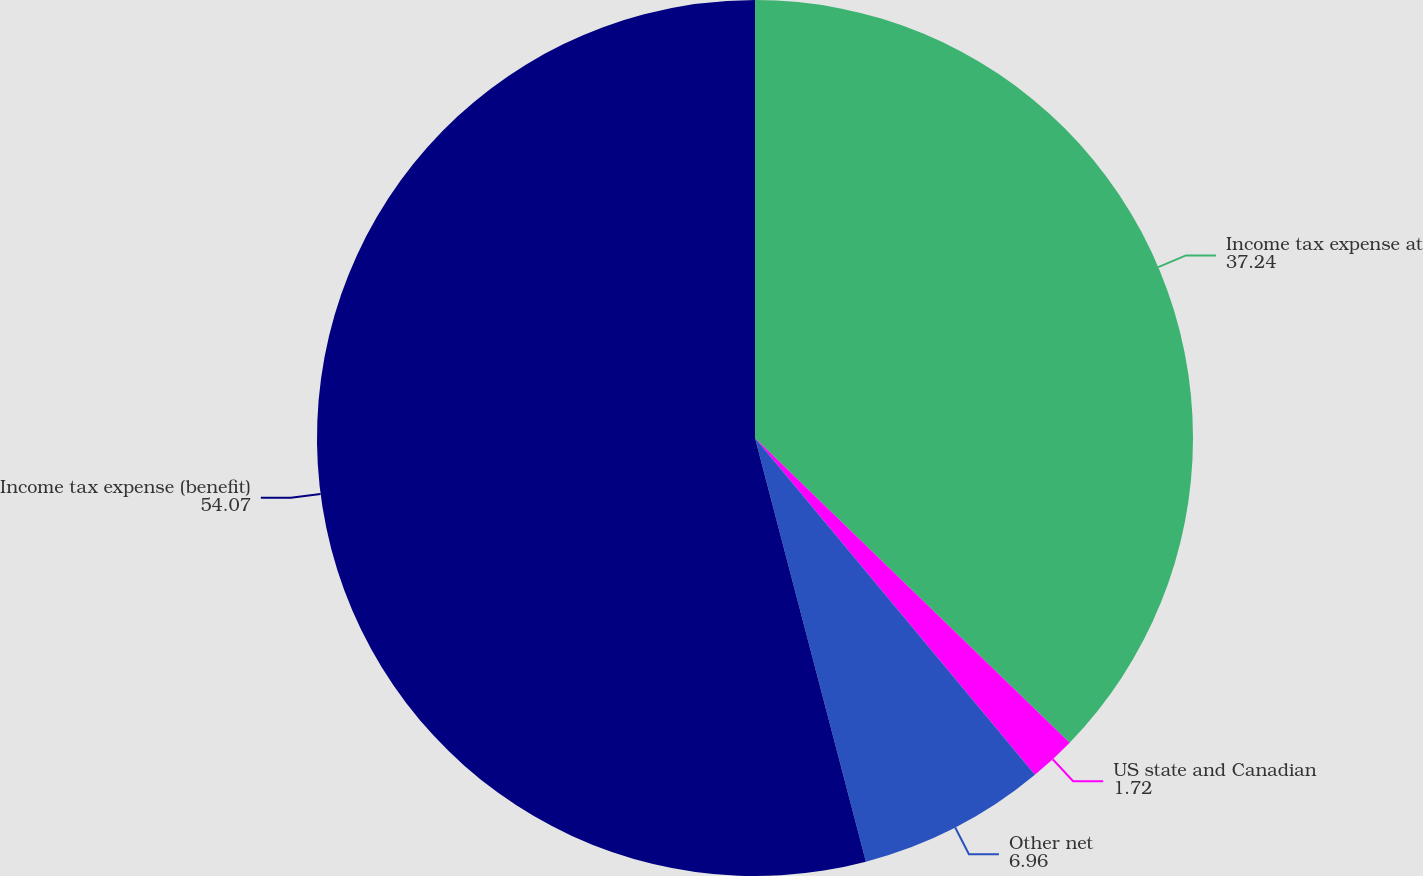Convert chart. <chart><loc_0><loc_0><loc_500><loc_500><pie_chart><fcel>Income tax expense at<fcel>US state and Canadian<fcel>Other net<fcel>Income tax expense (benefit)<nl><fcel>37.24%<fcel>1.72%<fcel>6.96%<fcel>54.07%<nl></chart> 